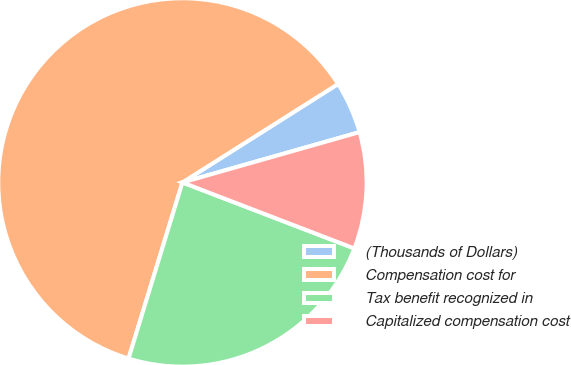Convert chart to OTSL. <chart><loc_0><loc_0><loc_500><loc_500><pie_chart><fcel>(Thousands of Dollars)<fcel>Compensation cost for<fcel>Tax benefit recognized in<fcel>Capitalized compensation cost<nl><fcel>4.57%<fcel>61.29%<fcel>23.89%<fcel>10.24%<nl></chart> 